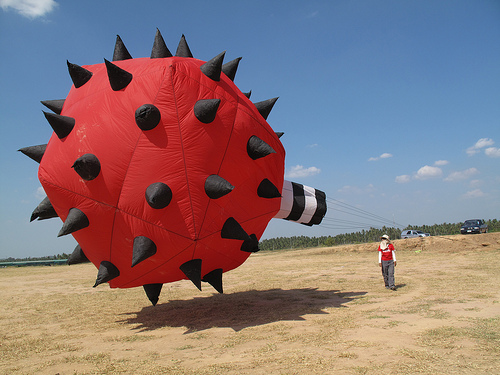<image>
Can you confirm if the balloon is next to the man? Yes. The balloon is positioned adjacent to the man, located nearby in the same general area. 